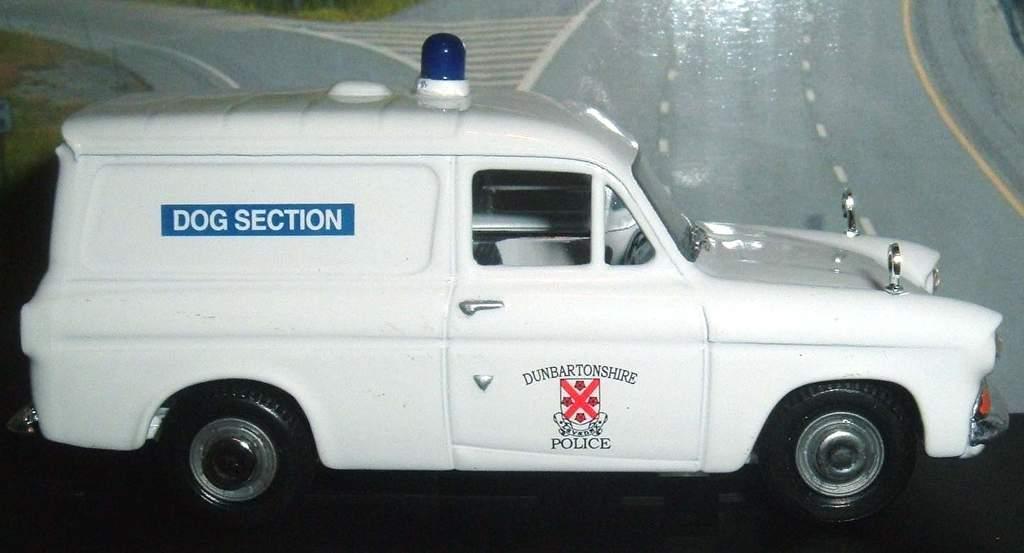How would you summarize this image in a sentence or two? In the picture we can see a van which is white in color and it is a police vehicle and a siren on it which is blue in color and beside it we can see a wall with a painting of a road on it. 